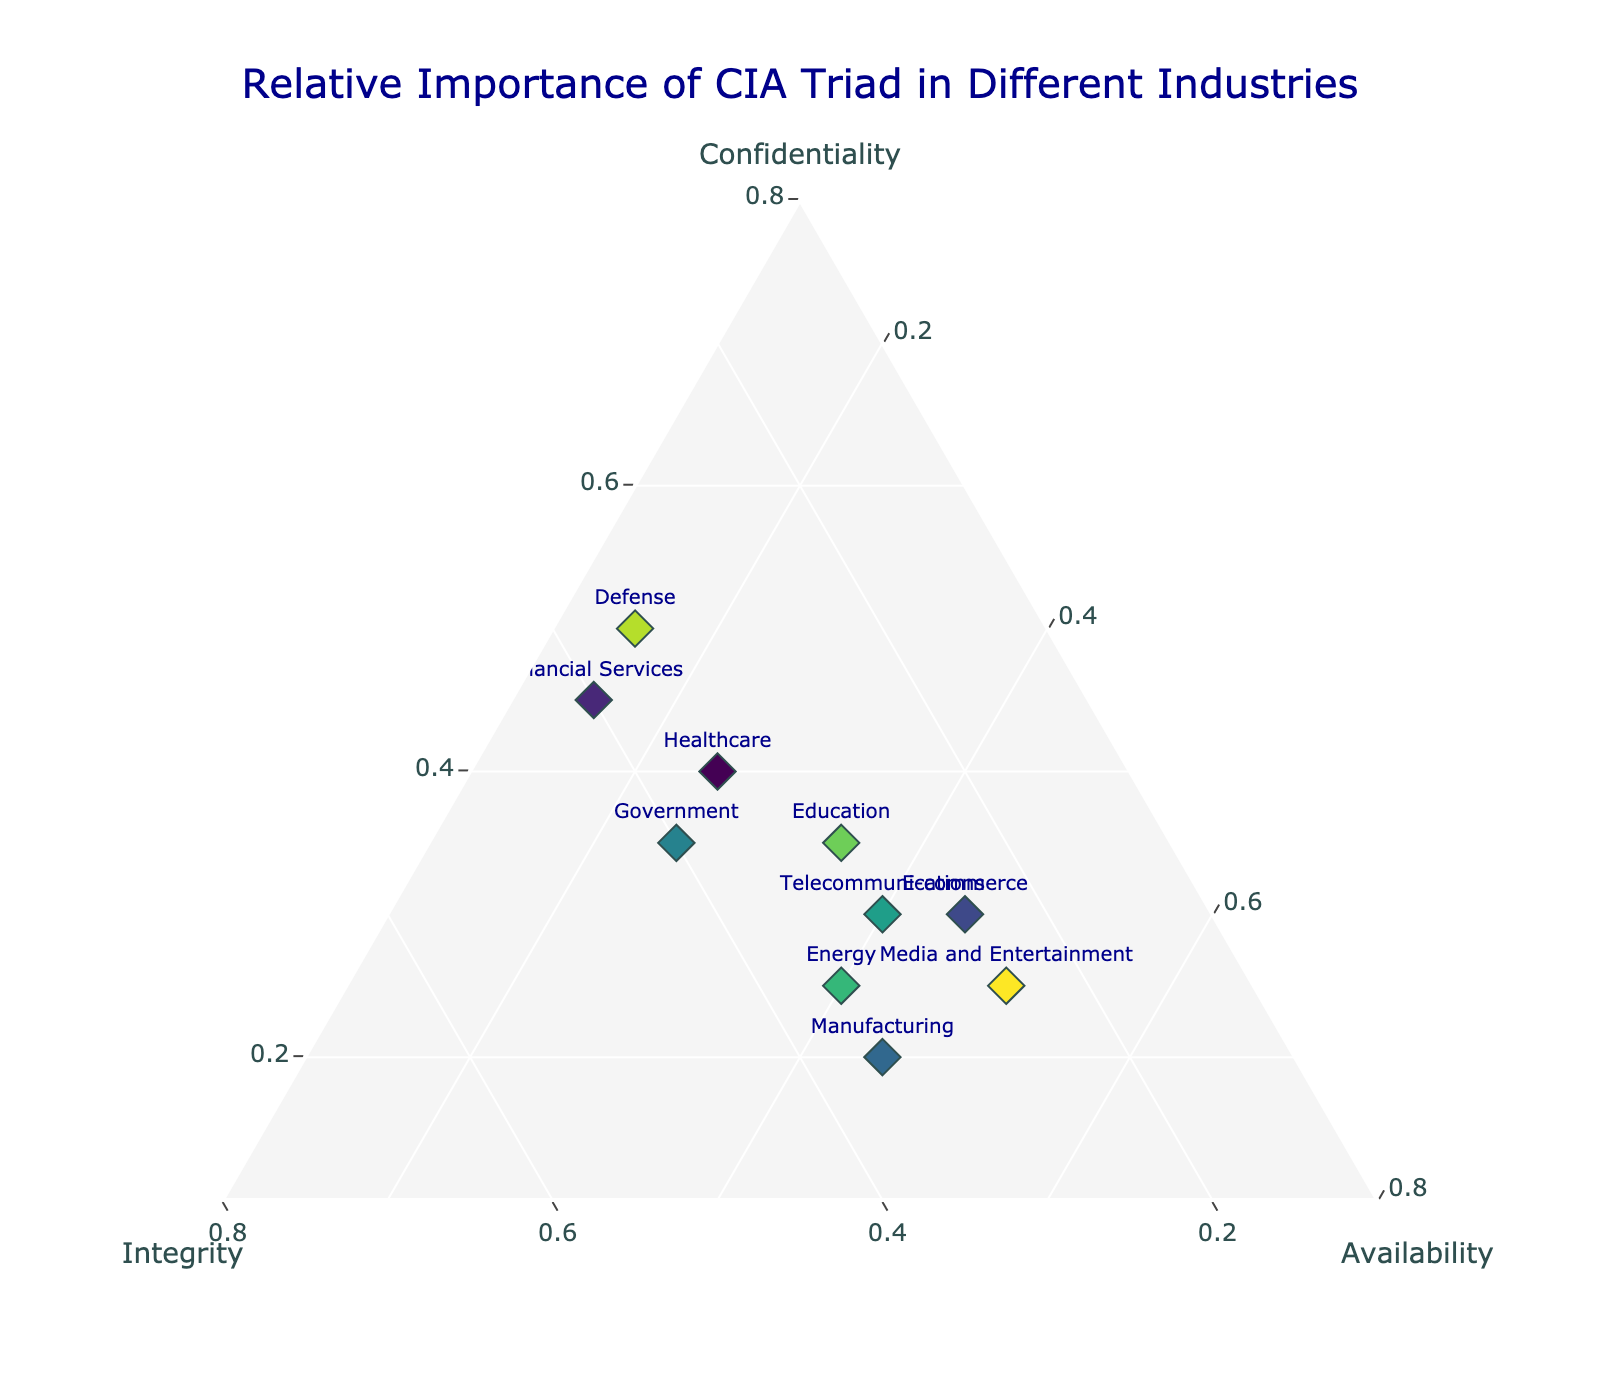What is the title of the ternary plot? The title appears at the top center of the plot and is displayed prominently to describe the figure. The title text is "Relative Importance of CIA Triad in Different Industries".
Answer: Relative Importance of CIA Triad in Different Industries Which industry places the highest importance on confidentiality? Look for the point with the highest value on the 'Confidentiality' axis. The 'Defense' sector is located at the point with the highest confidentiality value.
Answer: Defense How does the importance of integrity in the telecommunications sector compare to the availability in the same sector? Locate the 'Telecommunications' point and compare the integrity and availability values. The integrity value is 0.30, and the availability value is 0.40.
Answer: Availability is higher than integrity Which industries have a greater emphasis on availability compared to confidentiality? Identify industries where the data point is closer to the 'Availability' axis than the 'Confidentiality' axis. 'E-commerce', 'Manufacturing', 'Telecommunications', 'Energy', and 'Media and Entertainment' emphasize availability more than confidentiality.
Answer: E-commerce, Manufacturing, Telecommunications, Energy, Media and Entertainment What is the relative importance of the CIA components in the financial services industry? Check the positions of the financial services data point on the 'Confidentiality', 'Integrity', and 'Availability' axes. Financial Services has 0.45 for confidentiality, 0.40 for integrity, and 0.15 for availability.
Answer: Confidentiality: 0.45, Integrity: 0.40, Availability: 0.15 Which industry places the most balanced importance between confidentiality, integrity, and availability? Find the point closest to the center of the ternary plot where the values of confidentiality, integrity, and availability are most similar. The 'Education' sector shows values of 0.35 for confidentiality, 0.30 for integrity, and 0.35 for availability.
Answer: Education Which industry values availability equally to confidentiality the most? Check for the industry where the confidentiality and availability values are equal or nearly equal. The 'Education' sector has values of both confidentiality and availability at 0.35.
Answer: Education Between healthcare and government sectors, which one has a higher emphasis on integrity? Compare the positions of the healthcare and government points on the 'Integrity' axis. Healthcare has 0.35 for integrity, while Government has 0.40.
Answer: Government What is the average importance of confidentiality across all industries? Sum all the confidentiality values and divide by the number of industries. The sum is 0.40 + 0.45 + 0.30 + 0.20 + 0.35 + 0.30 + 0.25 + 0.35 + 0.50 + 0.25 = 3.35. There are 10 industries, so the average is 3.35/10 = 0.335.
Answer: 0.335 What is the total of importance values (confidentiality, integrity, availability) for the healthcare sector? Sum the values of confidentiality, integrity, and availability for the healthcare sector: 0.40 + 0.35 + 0.25 = 1.00.
Answer: 1.00 